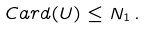<formula> <loc_0><loc_0><loc_500><loc_500>C a r d ( U ) \leq N _ { 1 } \, .</formula> 